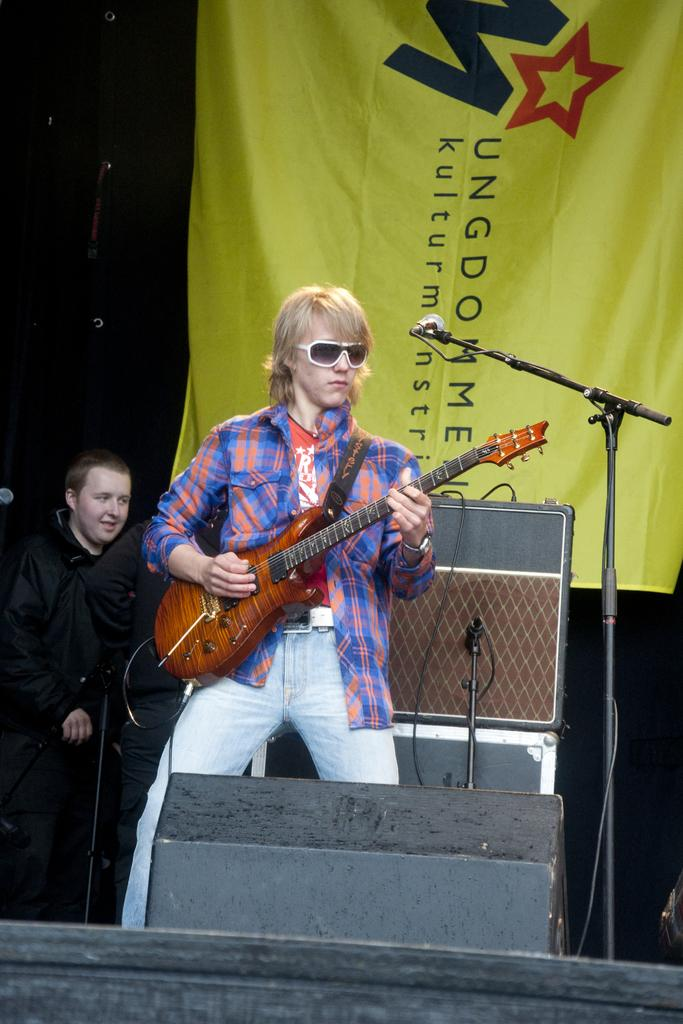How many people are in the image? There are three persons standing in the image. What is the person in the middle holding? The person in the middle is holding a guitar. What object is present for amplifying sound? There is a microphone in the image. What can be seen in the background of the image? There is a banner in the background of the image. How many dogs are participating in the competition in the image? There are no dogs or competition present in the image. What type of branch can be seen growing from the guitar in the image? There is no branch growing from the guitar in the image; it is a musical instrument. 